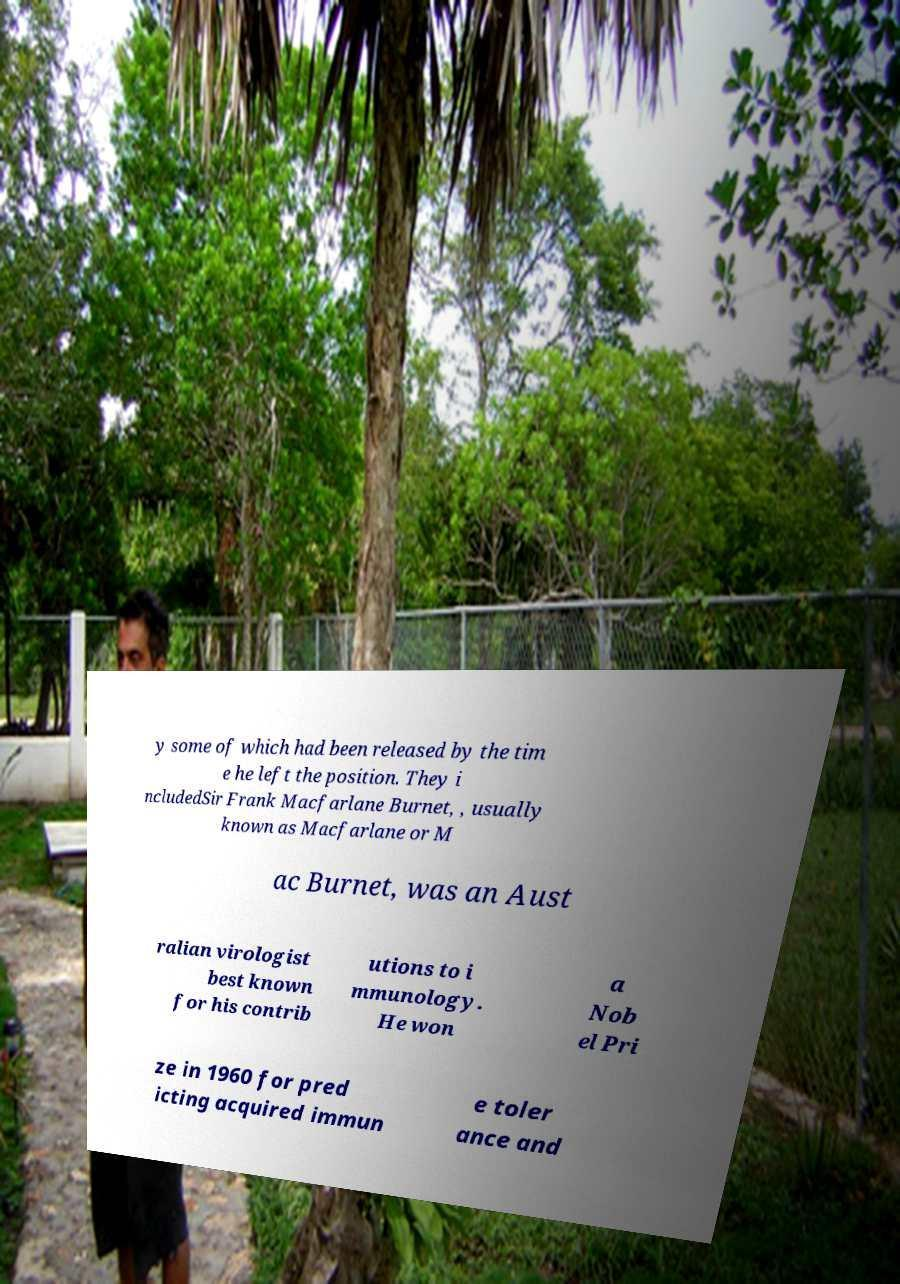Please read and relay the text visible in this image. What does it say? y some of which had been released by the tim e he left the position. They i ncludedSir Frank Macfarlane Burnet, , usually known as Macfarlane or M ac Burnet, was an Aust ralian virologist best known for his contrib utions to i mmunology. He won a Nob el Pri ze in 1960 for pred icting acquired immun e toler ance and 